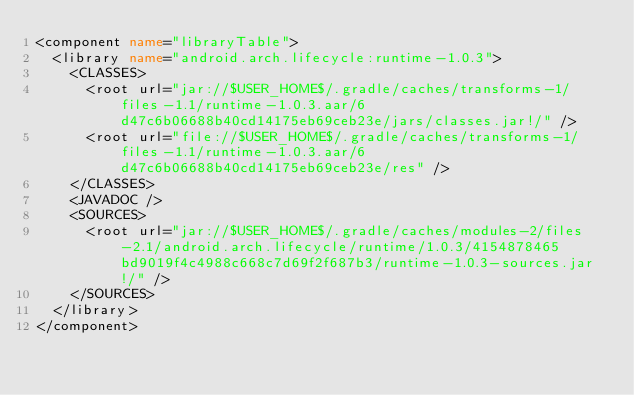Convert code to text. <code><loc_0><loc_0><loc_500><loc_500><_XML_><component name="libraryTable">
  <library name="android.arch.lifecycle:runtime-1.0.3">
    <CLASSES>
      <root url="jar://$USER_HOME$/.gradle/caches/transforms-1/files-1.1/runtime-1.0.3.aar/6d47c6b06688b40cd14175eb69ceb23e/jars/classes.jar!/" />
      <root url="file://$USER_HOME$/.gradle/caches/transforms-1/files-1.1/runtime-1.0.3.aar/6d47c6b06688b40cd14175eb69ceb23e/res" />
    </CLASSES>
    <JAVADOC />
    <SOURCES>
      <root url="jar://$USER_HOME$/.gradle/caches/modules-2/files-2.1/android.arch.lifecycle/runtime/1.0.3/4154878465bd9019f4c4988c668c7d69f2f687b3/runtime-1.0.3-sources.jar!/" />
    </SOURCES>
  </library>
</component></code> 